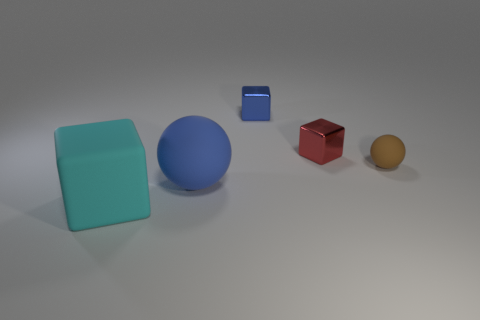Add 2 small yellow matte cylinders. How many objects exist? 7 Subtract all cubes. How many objects are left? 2 Add 1 cyan matte things. How many cyan matte things exist? 2 Subtract 0 purple spheres. How many objects are left? 5 Subtract all small red shiny blocks. Subtract all brown things. How many objects are left? 3 Add 3 big cyan things. How many big cyan things are left? 4 